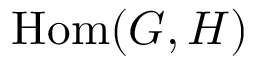<formula> <loc_0><loc_0><loc_500><loc_500>{ H o m } ( G , H )</formula> 